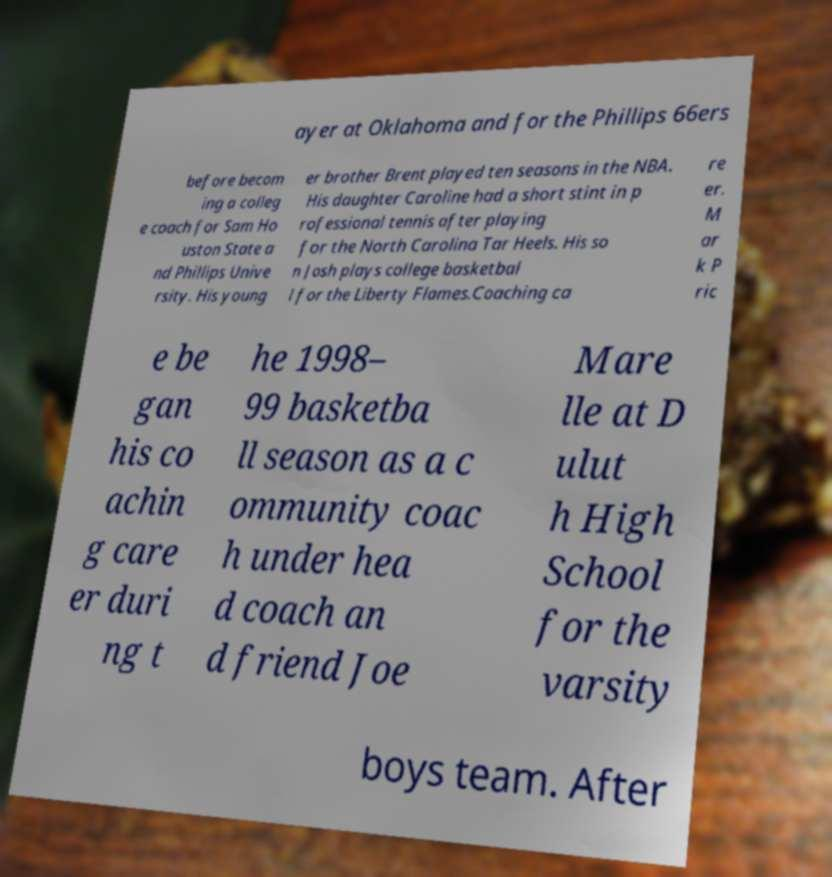What messages or text are displayed in this image? I need them in a readable, typed format. ayer at Oklahoma and for the Phillips 66ers before becom ing a colleg e coach for Sam Ho uston State a nd Phillips Unive rsity. His young er brother Brent played ten seasons in the NBA. His daughter Caroline had a short stint in p rofessional tennis after playing for the North Carolina Tar Heels. His so n Josh plays college basketbal l for the Liberty Flames.Coaching ca re er. M ar k P ric e be gan his co achin g care er duri ng t he 1998– 99 basketba ll season as a c ommunity coac h under hea d coach an d friend Joe Mare lle at D ulut h High School for the varsity boys team. After 